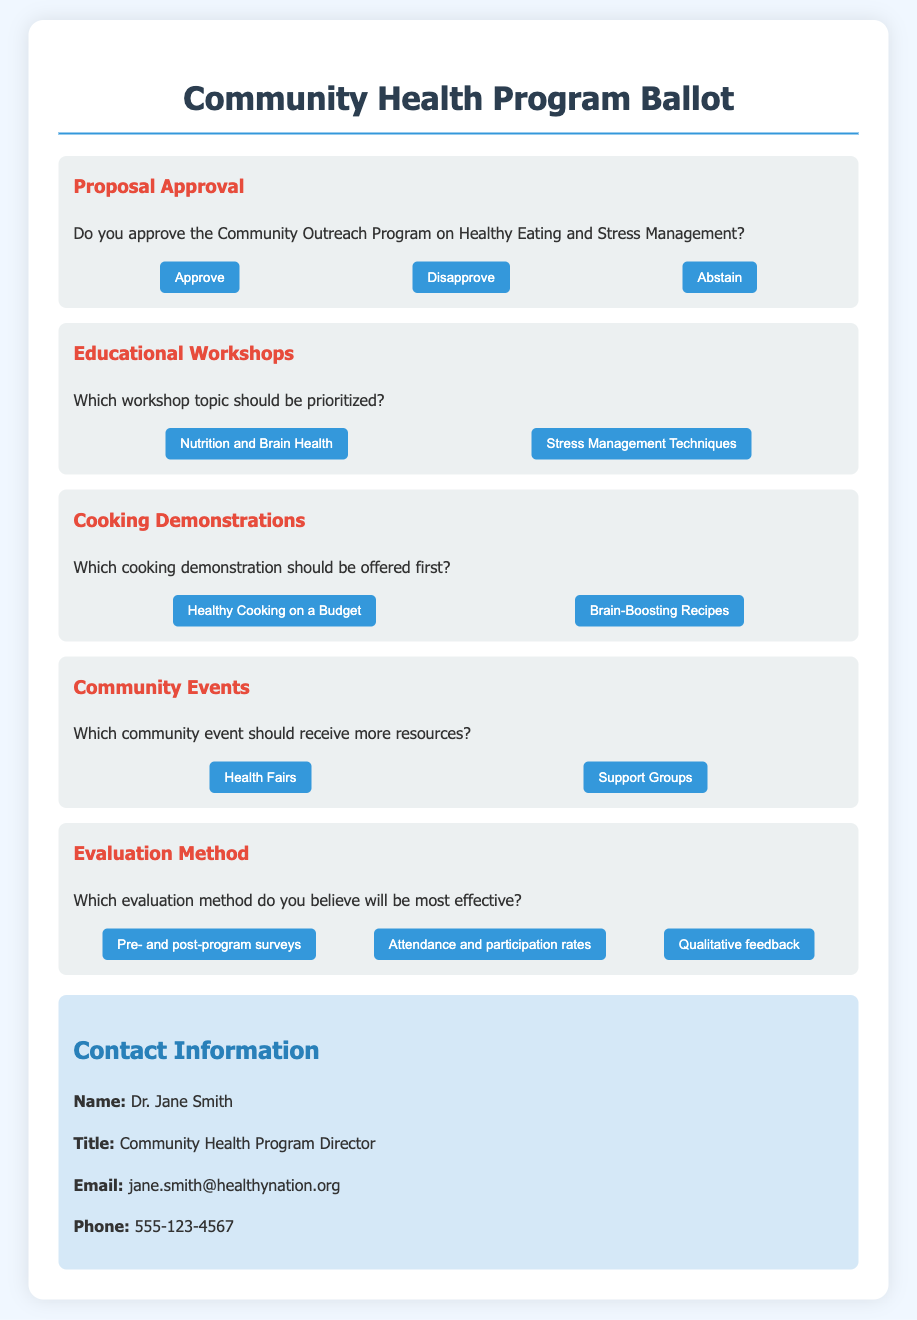What is the title of the ballot? The title of the ballot is provided at the top of the document.
Answer: Community Health Program Ballot Who is the Community Health Program Director? The director's name is specified in the contact information section at the end of the document.
Answer: Dr. Jane Smith What are the two workshop topics listed for prioritization? The document specifies workshop topics under the educational workshops section.
Answer: Nutrition and Brain Health, Stress Management Techniques Which cooking demonstration is proposed to be offered first? The document asks for a priority choice among two cooking demonstration options.
Answer: Healthy Cooking on a Budget What evaluation method is suggested for effectiveness? The ballot lists three evaluation methods for respondents to consider in making their choice.
Answer: Pre- and post-program surveys How many options are provided for the Proposal Approval question? The number of voting options is explicitly stated in the proposal approval section of the document.
Answer: Three Which event is prioritized for more resources? The document identifies two community events and asks for a preference among them.
Answer: Health Fairs What is the contact email for Dr. Jane Smith? The director's email address is listed under the contact information section.
Answer: jane.smith@healthynation.org Which color is used for the header of the ballot item sections? The document describes the color styling for headers in the ballot item sections.
Answer: Red 